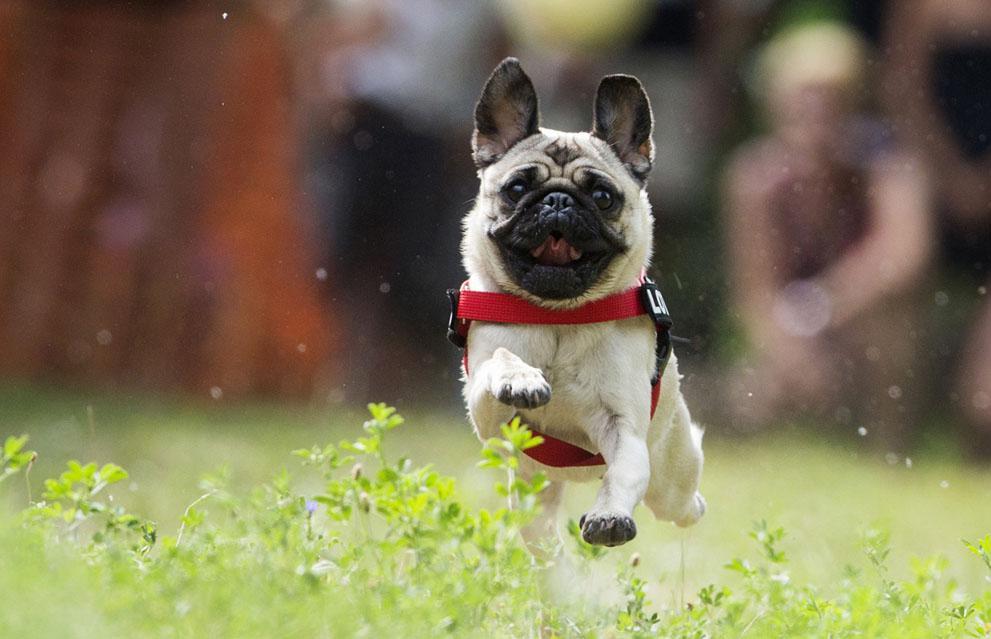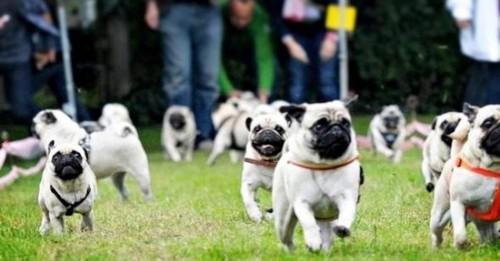The first image is the image on the left, the second image is the image on the right. Examine the images to the left and right. Is the description "There is at least one black pug running through the grass." accurate? Answer yes or no. No. 